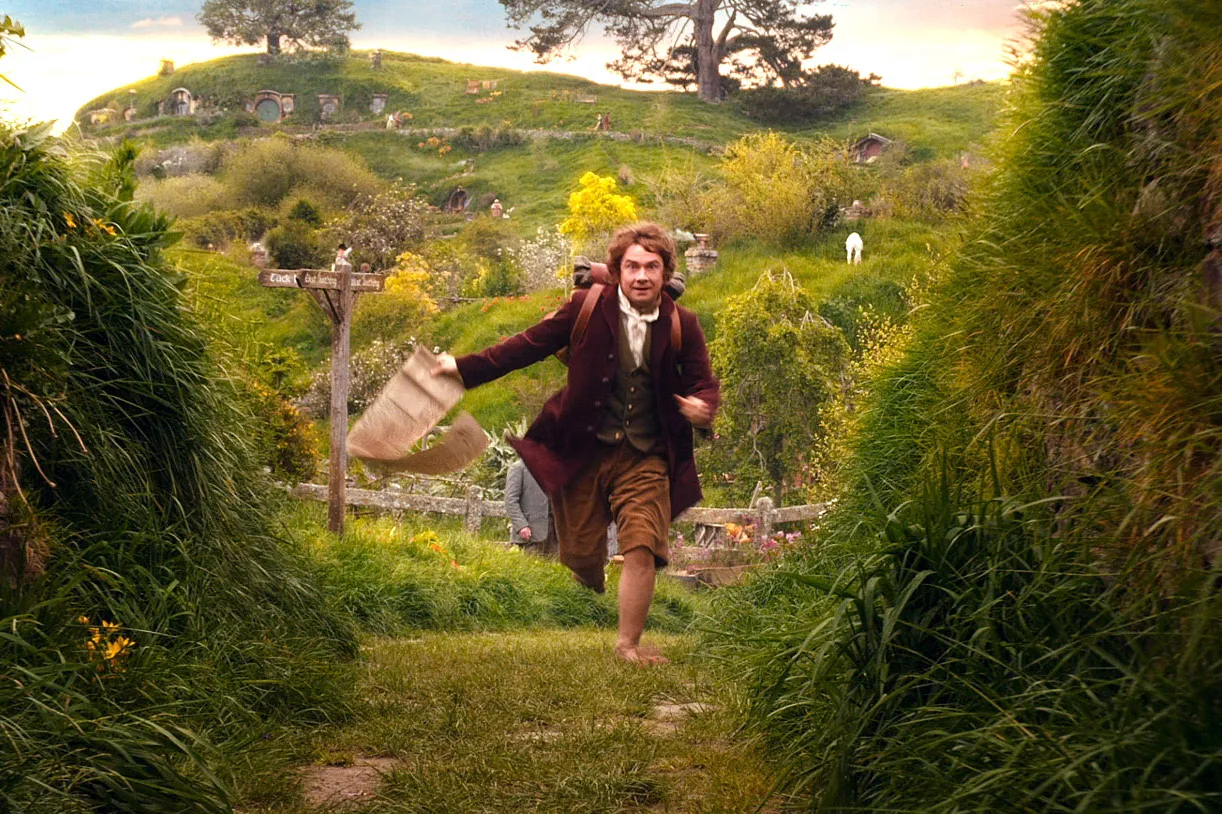What does the sign in the background signify in this scene? The sign reading 'Bag End' is highly significant as it indicates this scene takes place near the home of Bilbo Baggins, the main character in 'The Hobbit'. It sets the stage for the adventures that begin from this very point, adding a layer of anticipation and context to the image. 